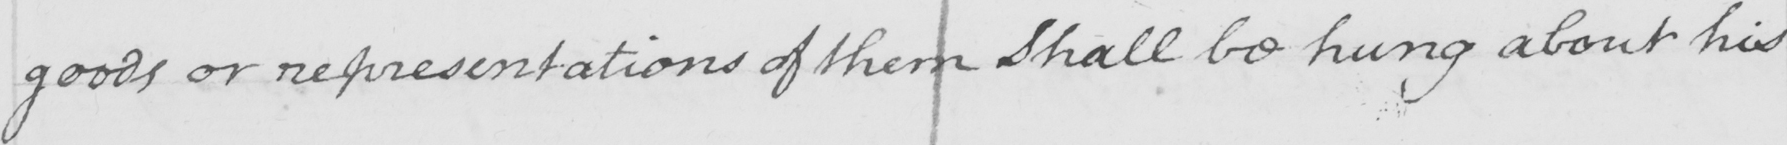What is written in this line of handwriting? goods or representations of them Shall be hung about his 